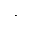Convert formula to latex. <formula><loc_0><loc_0><loc_500><loc_500>\cdot</formula> 